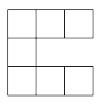$7$ congruent squares are arranged into a 'C,' as shown below. If the perimeter and area of the 'C' are equal (ignoring units), compute the (nonzero) side length of the squares. To find the side length $s$ of the squares where both the perimeter and area of the 'C' configuration are equal, we start by confirming the configuration contains 7 squares. The perimeter of this shape equals the total length of the exposed edges in the 'C' formation, which is 16s. The area of the figure is simply the area of each square added together, which is $7s^2$. Setting the perimeter equal to the area gives us the equation $16s = 7s^2$. Solving for $s$, we rearrange to get $7s^2 - 16s = 0$. Factoring out $s$, we get $s(7s - 16) = 0$. The solutions to this are $s = 0$ or $s = 16/7$. Since a side length cannot be zero, the side length of each square is $s = 16/7$. This value ensures the perimeter and area are equal, demonstrating an interesting property of this unique geometric arrangement. 